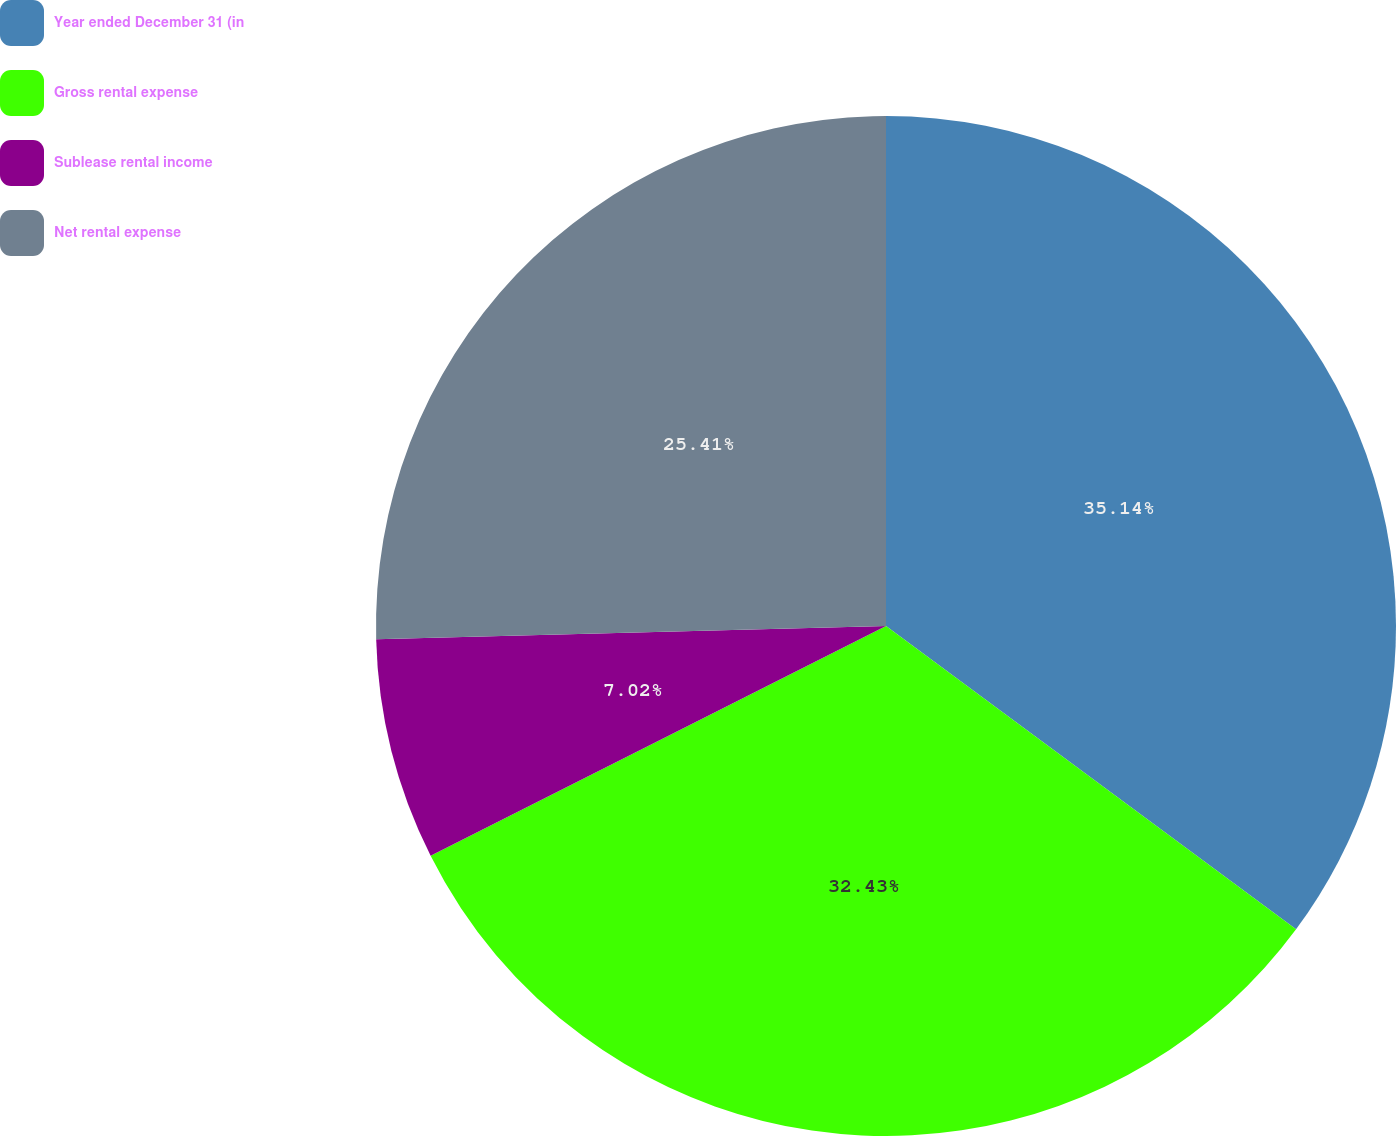Convert chart. <chart><loc_0><loc_0><loc_500><loc_500><pie_chart><fcel>Year ended December 31 (in<fcel>Gross rental expense<fcel>Sublease rental income<fcel>Net rental expense<nl><fcel>35.13%<fcel>32.43%<fcel>7.02%<fcel>25.41%<nl></chart> 